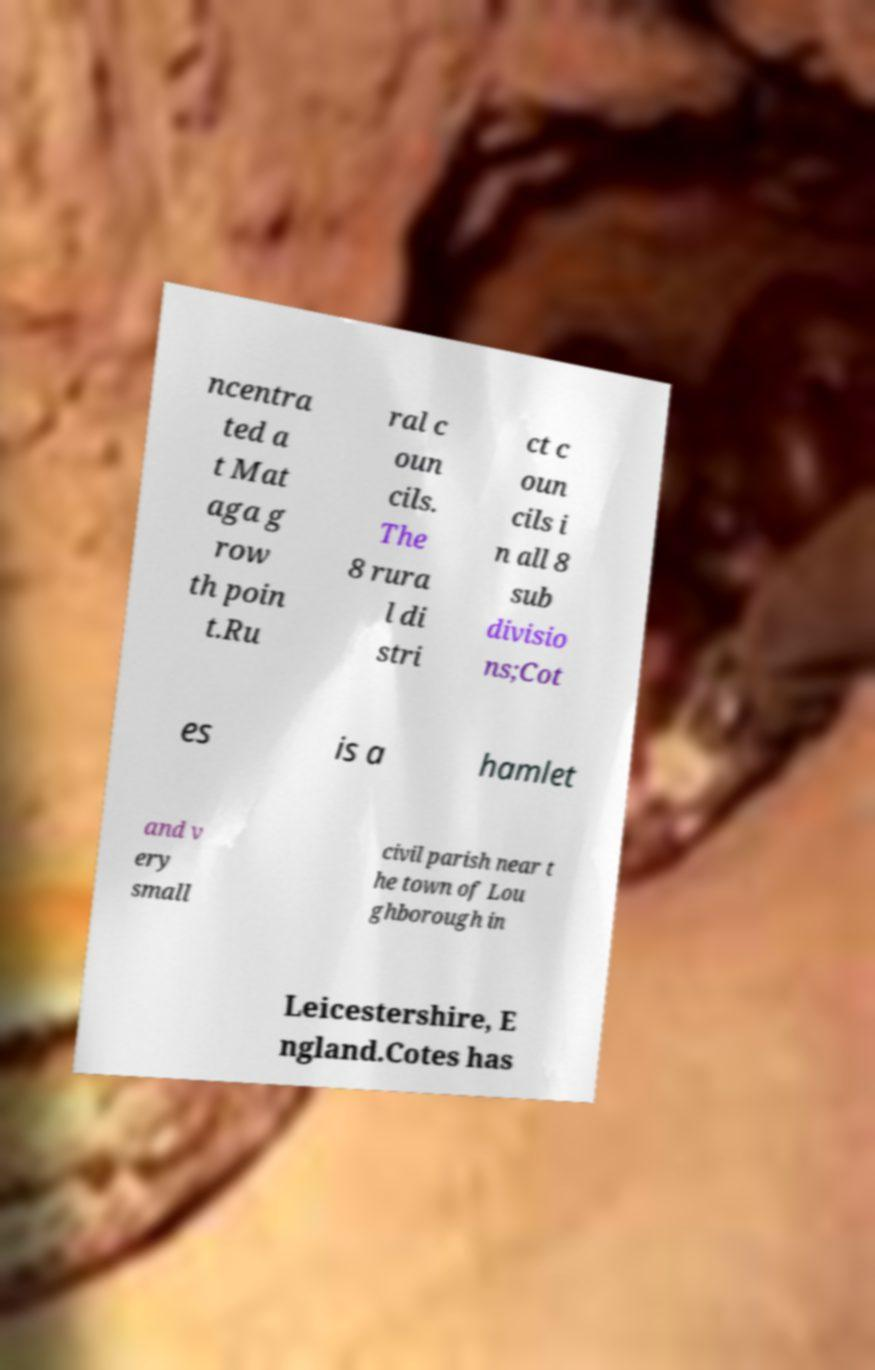Please identify and transcribe the text found in this image. ncentra ted a t Mat aga g row th poin t.Ru ral c oun cils. The 8 rura l di stri ct c oun cils i n all 8 sub divisio ns;Cot es is a hamlet and v ery small civil parish near t he town of Lou ghborough in Leicestershire, E ngland.Cotes has 